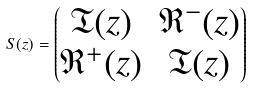Convert formula to latex. <formula><loc_0><loc_0><loc_500><loc_500>S ( z ) = \begin{pmatrix} \mathfrak T ( z ) & \mathfrak R ^ { - } ( z ) \\ \mathfrak R ^ { + } ( z ) & \mathfrak T ( z ) \end{pmatrix}</formula> 